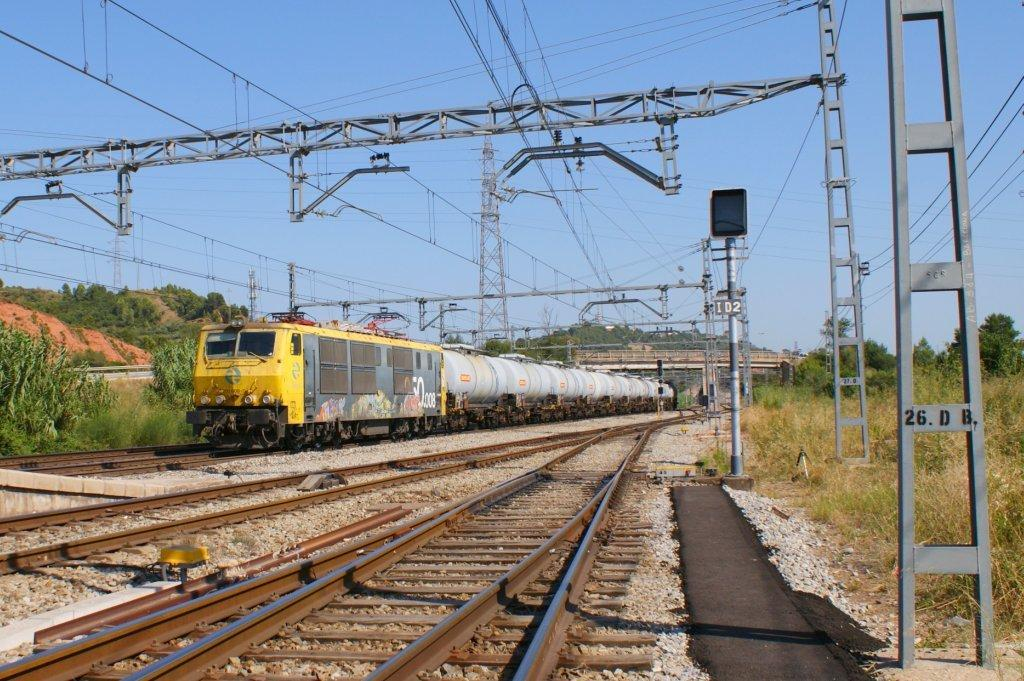What is the main subject of the image? The main subject of the image is a train. Where is the train located in the image? The train is on a track in the image. What can be seen in the background of the image? There is a bridge and trees in the background of the image. What other objects are visible in the image? There are poles and tracks visible in the image. How many apples are hanging from the train in the image? There are no apples present in the image, and therefore no such objects can be observed hanging from the train. Can you see a plane flying over the train in the image? There is no plane visible in the image; it only features a train, tracks, poles, and a background with a bridge and trees. 